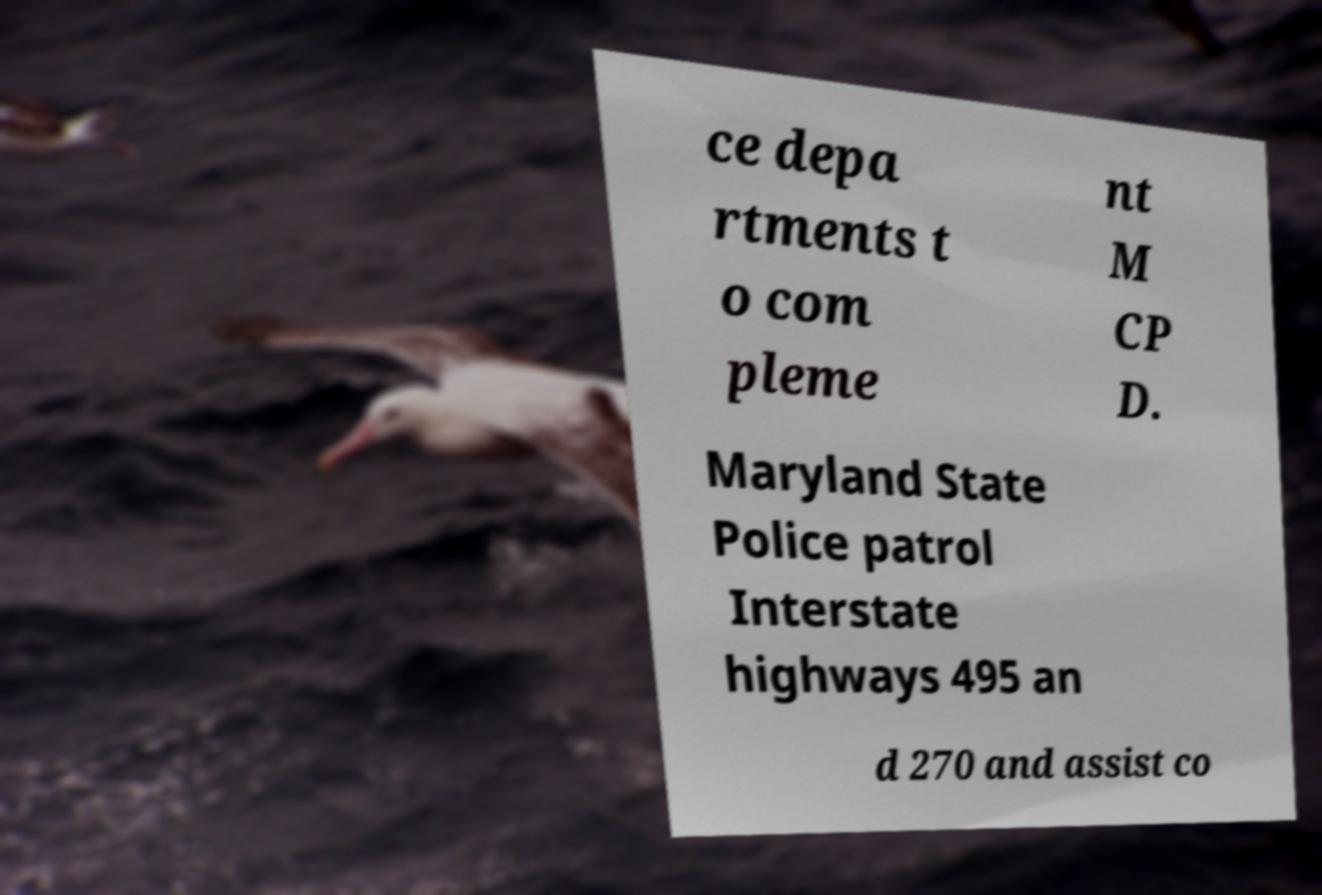Please read and relay the text visible in this image. What does it say? ce depa rtments t o com pleme nt M CP D. Maryland State Police patrol Interstate highways 495 an d 270 and assist co 